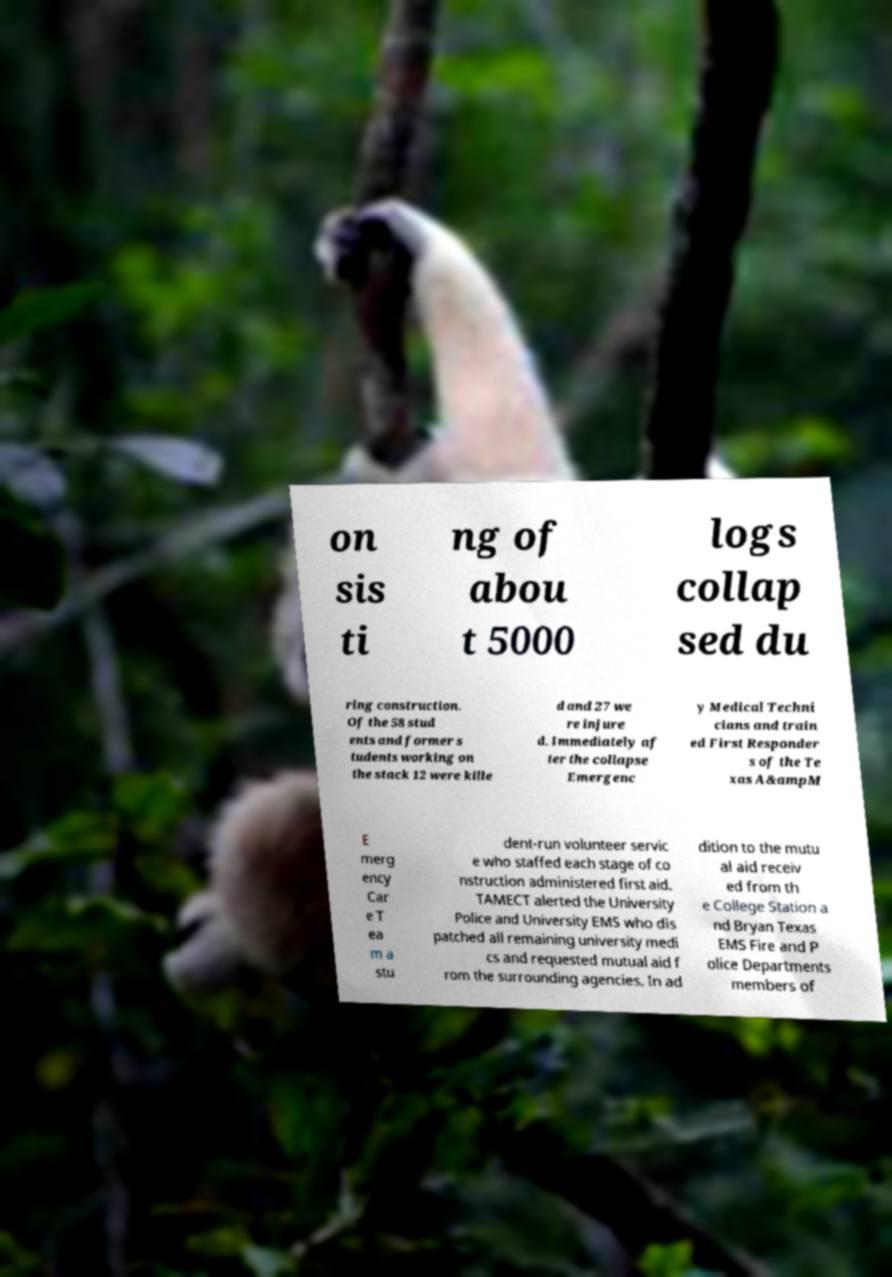Please read and relay the text visible in this image. What does it say? on sis ti ng of abou t 5000 logs collap sed du ring construction. Of the 58 stud ents and former s tudents working on the stack 12 were kille d and 27 we re injure d. Immediately af ter the collapse Emergenc y Medical Techni cians and train ed First Responder s of the Te xas A&ampM E merg ency Car e T ea m a stu dent-run volunteer servic e who staffed each stage of co nstruction administered first aid. TAMECT alerted the University Police and University EMS who dis patched all remaining university medi cs and requested mutual aid f rom the surrounding agencies. In ad dition to the mutu al aid receiv ed from th e College Station a nd Bryan Texas EMS Fire and P olice Departments members of 